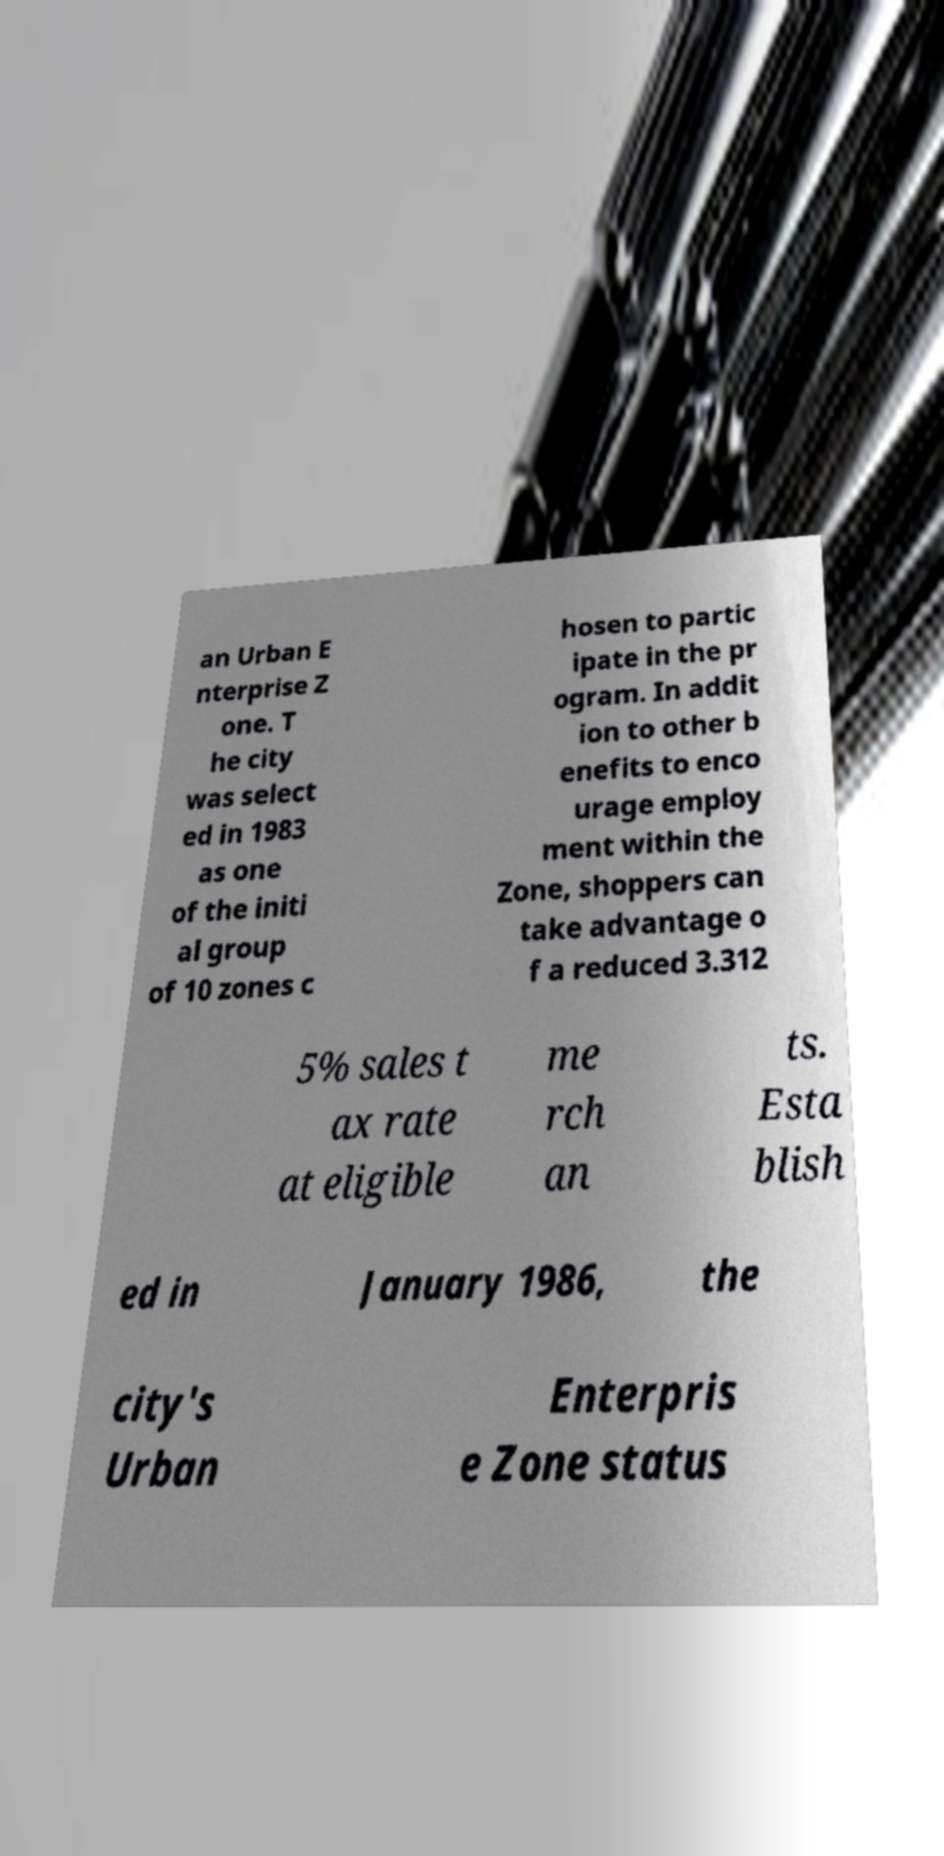I need the written content from this picture converted into text. Can you do that? an Urban E nterprise Z one. T he city was select ed in 1983 as one of the initi al group of 10 zones c hosen to partic ipate in the pr ogram. In addit ion to other b enefits to enco urage employ ment within the Zone, shoppers can take advantage o f a reduced 3.312 5% sales t ax rate at eligible me rch an ts. Esta blish ed in January 1986, the city's Urban Enterpris e Zone status 